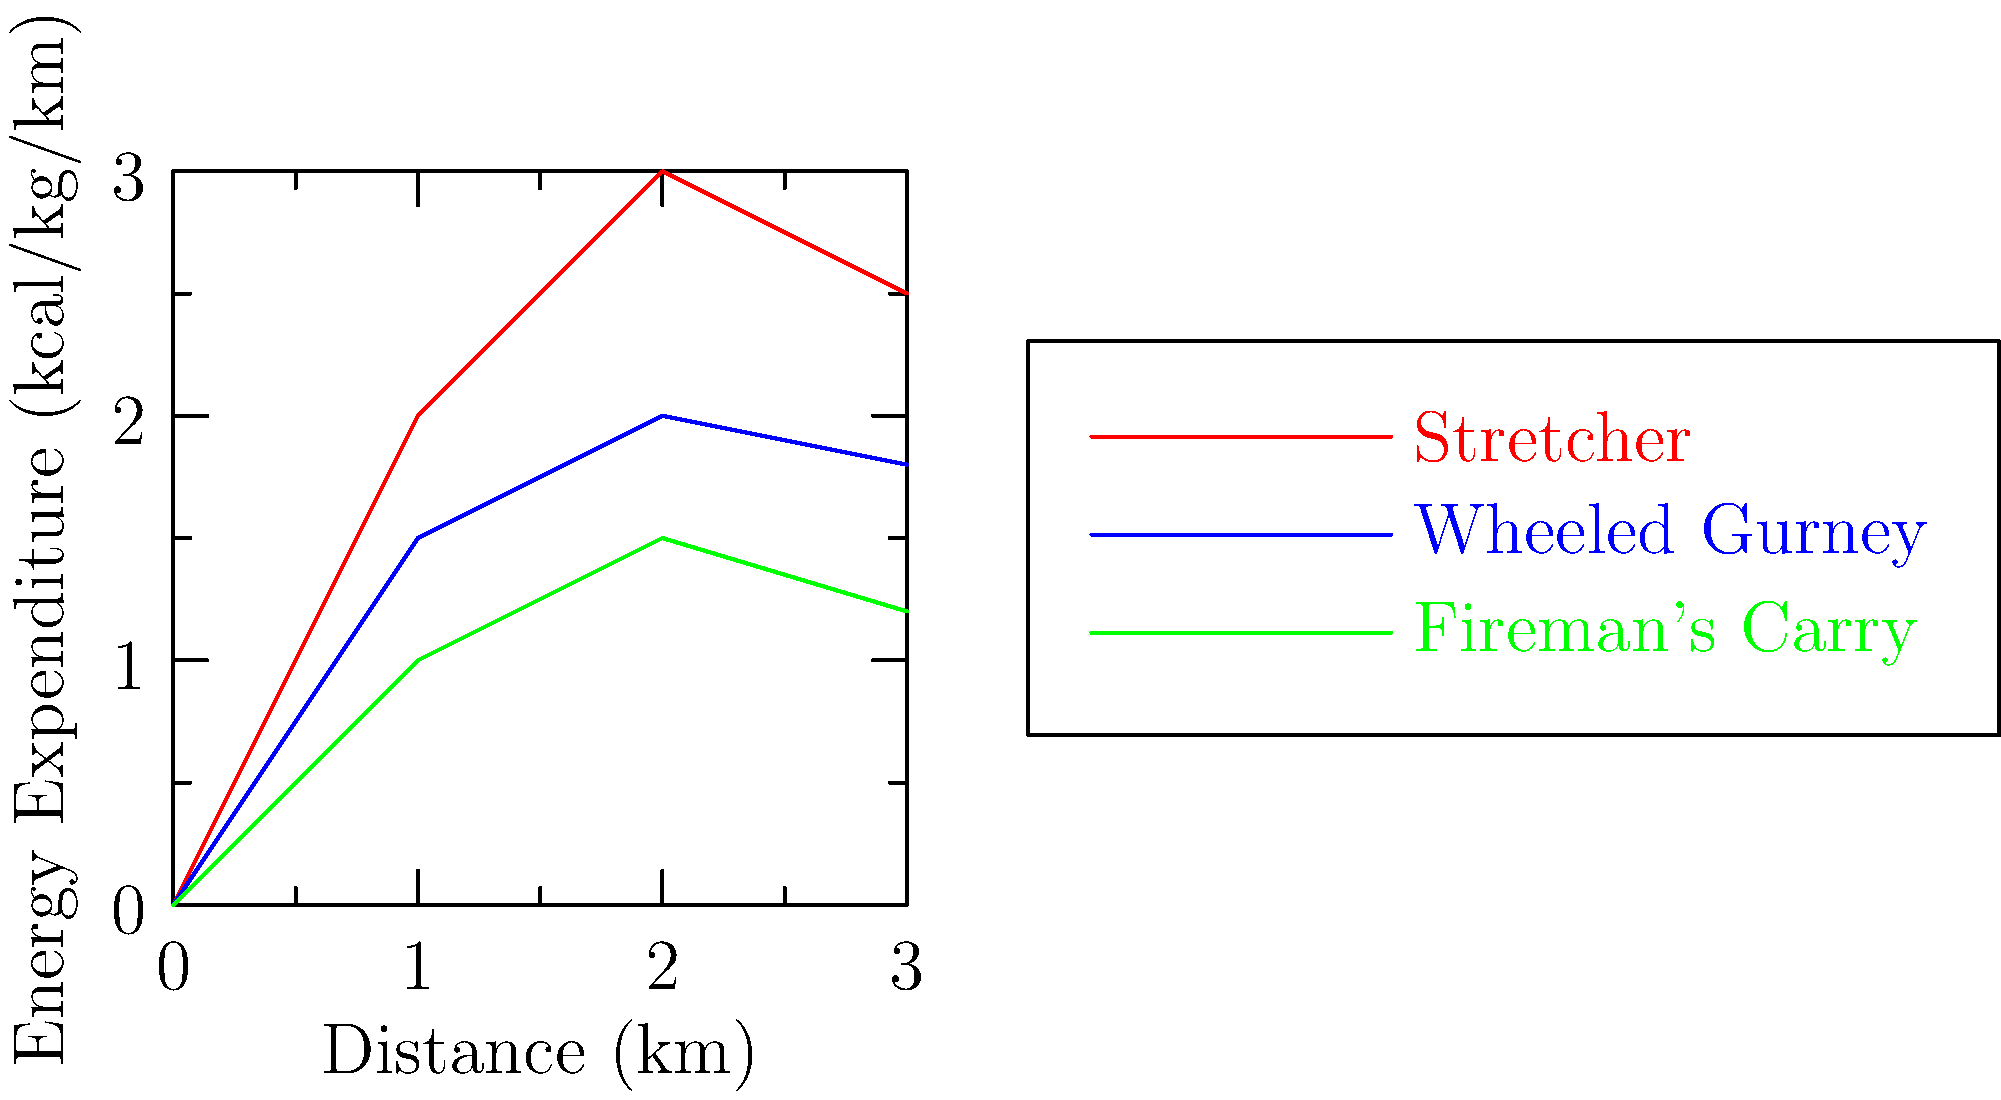Based on the graph showing energy expenditure for different patient transportation methods in disaster scenarios, which method requires the highest energy expenditure over a 3 km distance, and what is the approximate difference in energy expenditure (in kcal/kg) between this method and the most efficient method at the 3 km mark? To answer this question, we need to follow these steps:

1. Identify the method with the highest energy expenditure:
   Looking at the graph, the red line representing the stretcher method is consistently the highest.

2. Identify the most efficient method:
   The green line representing the fireman's carry is the lowest, indicating it's the most efficient.

3. Determine the energy expenditure values at 3 km:
   - Stretcher (red line): approximately 2.5 kcal/kg
   - Fireman's Carry (green line): approximately 1.2 kcal/kg

4. Calculate the difference:
   $$2.5 \text{ kcal/kg} - 1.2 \text{ kcal/kg} = 1.3 \text{ kcal/kg}$$

Therefore, the stretcher method requires the highest energy expenditure, and the difference between it and the most efficient method (fireman's carry) at the 3 km mark is approximately 1.3 kcal/kg.
Answer: Stretcher; 1.3 kcal/kg 